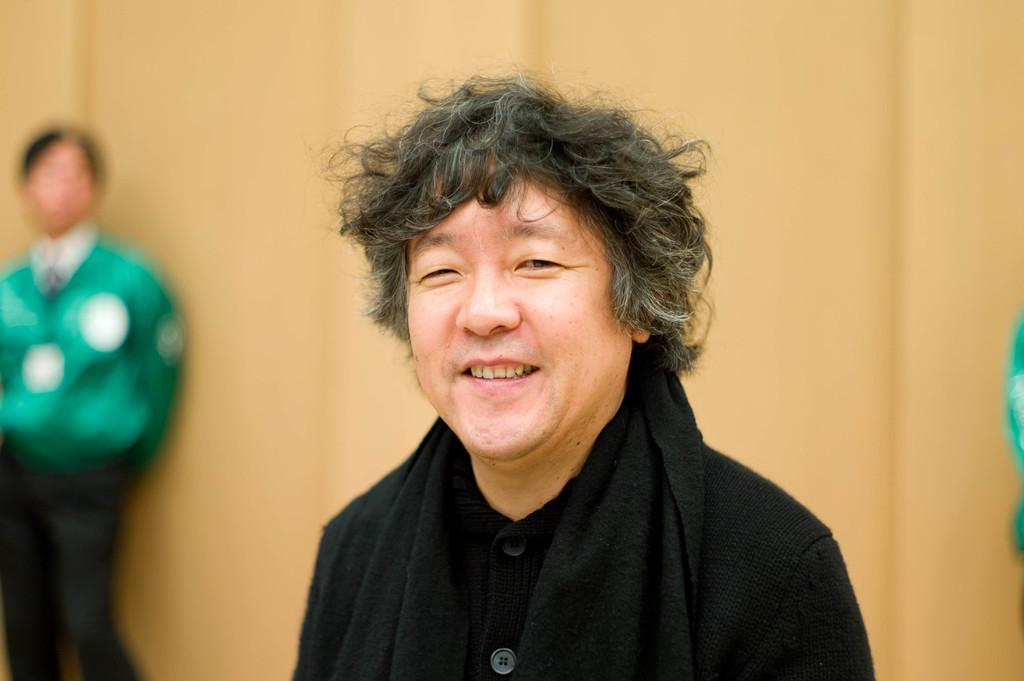What is the person in the center of the image wearing? There is a person wearing a black dress in the center of the image. Who else is present in the image? There is a man standing on the left side of the image. What can be seen in the background of the image? There is a wall in the background of the image. What type of music is being played in the class in the image? There is no class or music present in the image; it features a person wearing a black dress and a man standing on the left side of the image with a wall in the background. 